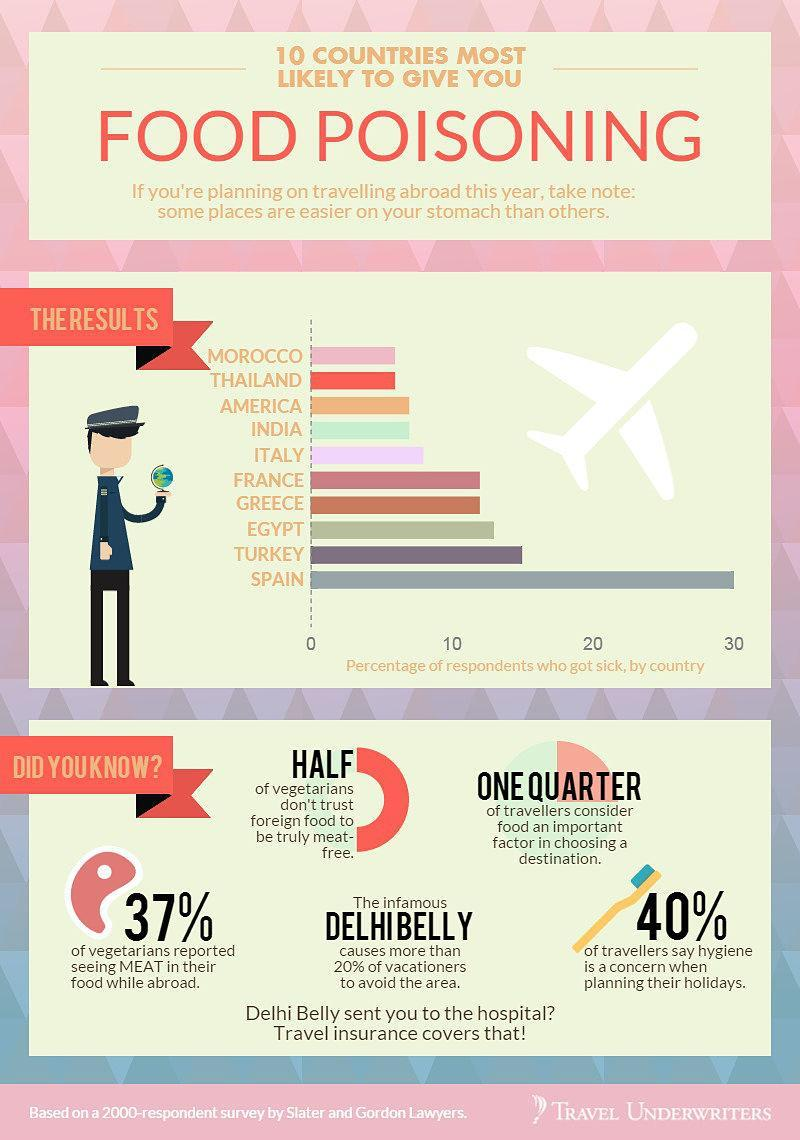Other than Greece, which countries have food poisoning cases in the range of 10-20
Answer the question with a short phrase. France, Egypt, Turkey Delhibelly is linked to which country India What % of travellers think food an importsnt factor while choosing destination 25 Turkey is lesser in food poisoning cases than which country Spain What concern when planning their holidays does the toothbrush indicate hygiene what is the colour of the aeroplane - red or white white What % of foreigners dont trust foreign food to be truly meat-free 50 